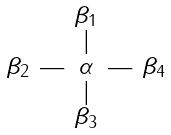<formula> <loc_0><loc_0><loc_500><loc_500>\begin{smallmatrix} & & \beta _ { 1 } & & \\ & & | & & \\ \beta _ { 2 } & \text {---} & \alpha & \text {---} & \beta _ { 4 } \\ & & | & & \\ & & \beta _ { 3 } & & \\ \end{smallmatrix}</formula> 